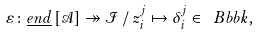<formula> <loc_0><loc_0><loc_500><loc_500>\varepsilon \colon \underline { e n d } \left [ \mathcal { A } \right ] \twoheadrightarrow \mathcal { I } \, / \, z _ { i } ^ { j } \mapsto \delta _ { i } ^ { j } \in \ B b b k ,</formula> 